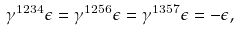Convert formula to latex. <formula><loc_0><loc_0><loc_500><loc_500>\gamma ^ { 1 2 3 4 } \epsilon = \gamma ^ { 1 2 5 6 } \epsilon = \gamma ^ { 1 3 5 7 } \epsilon = - \epsilon ,</formula> 